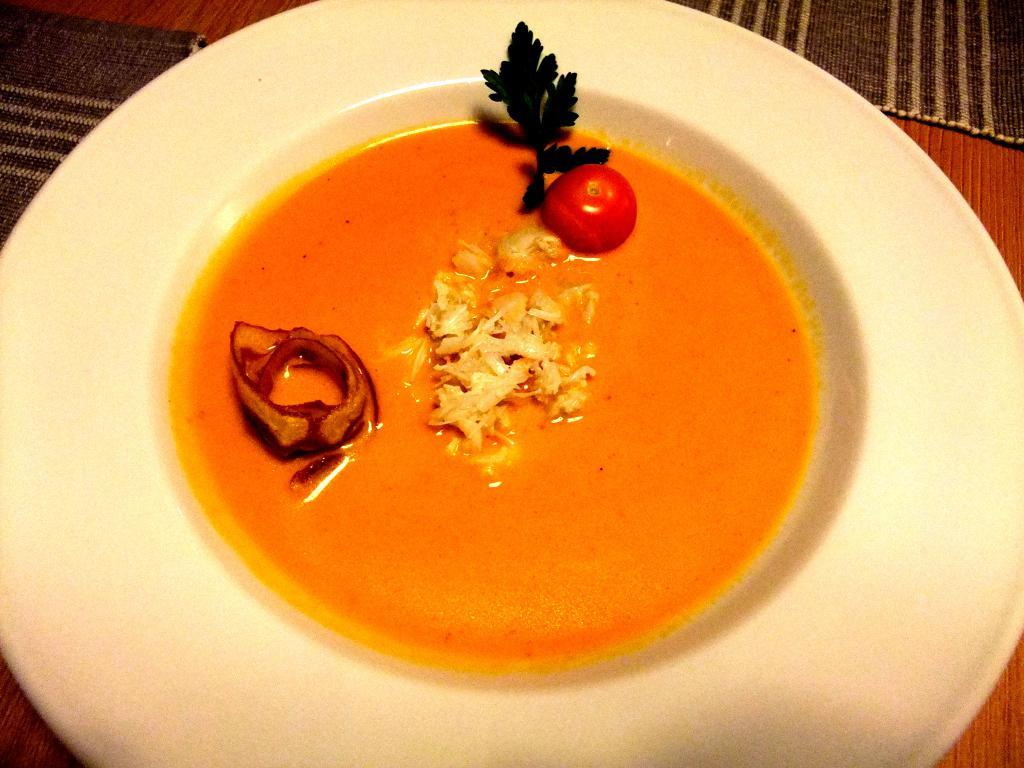What is on the plate that is visible in the image? There is food on a plate in the image. Where is the plate located in the image? The plate is in the center of the image. How many horses are present in the image? There are no horses present in the image; it only features a plate of food. What is the value of the food on the plate in the image? The value of the food cannot be determined from the image alone, as it depends on various factors such as the type of food, its quality, and the context in which it is being served. 